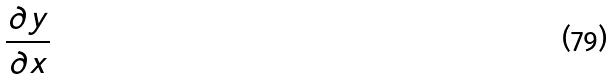<formula> <loc_0><loc_0><loc_500><loc_500>\frac { \partial y } { \partial x }</formula> 